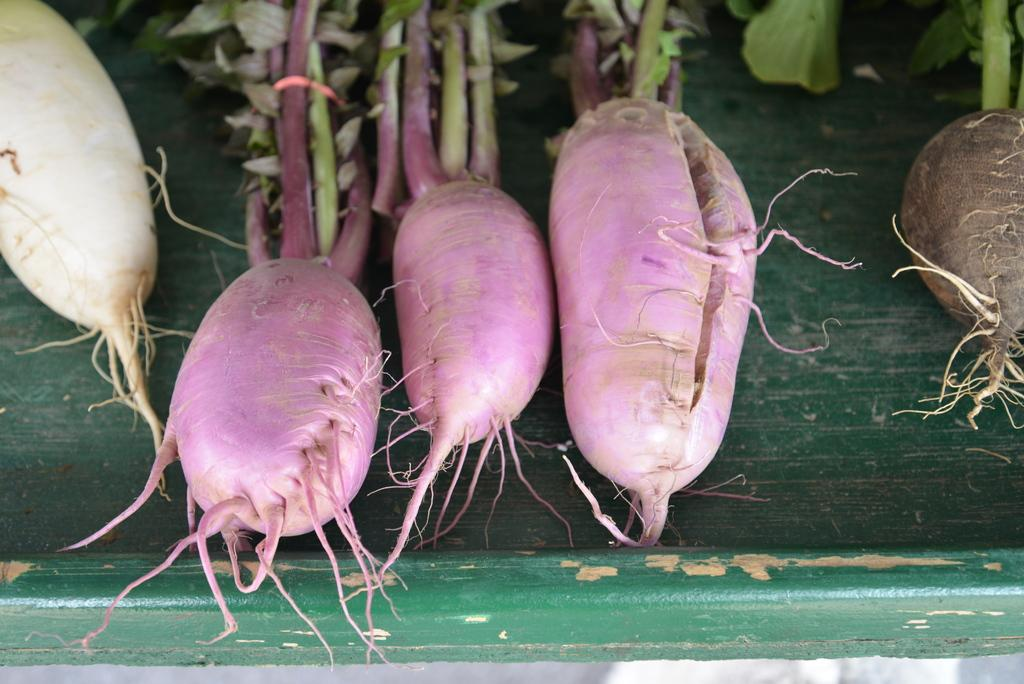What type of living organisms can be seen in the image? Plants can be seen in the image. What color do the plants have in common? The plants have different shades of red color. What type of fiction can be seen in the image? There is no fiction present in the image; it features plants with different shades of red color. Can you tell me how many boots are visible in the image? There are no boots present in the image. 